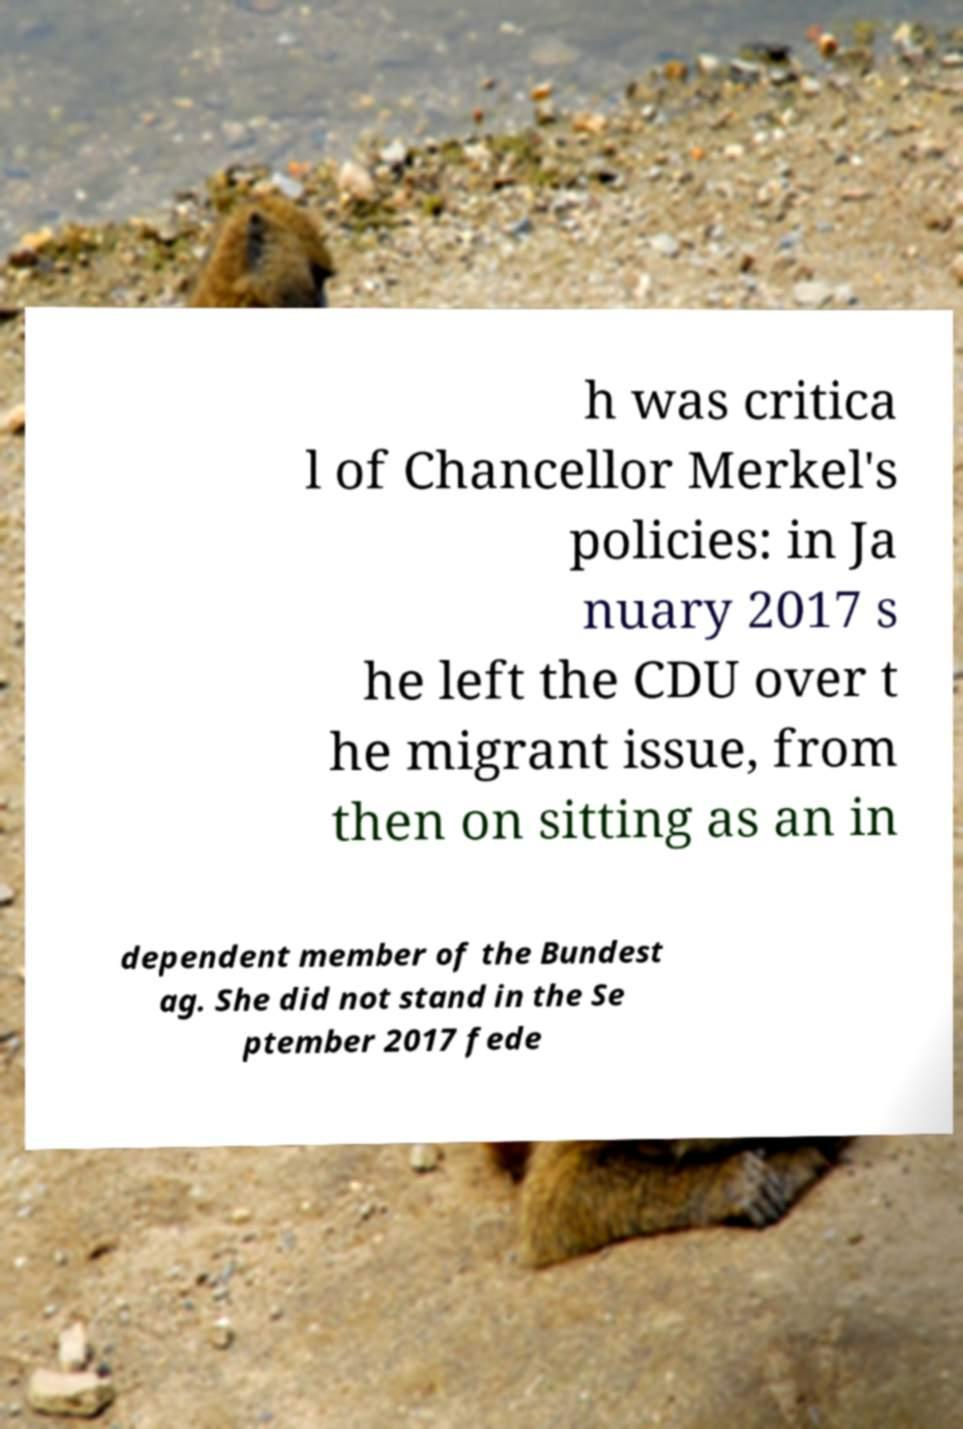Can you accurately transcribe the text from the provided image for me? h was critica l of Chancellor Merkel's policies: in Ja nuary 2017 s he left the CDU over t he migrant issue, from then on sitting as an in dependent member of the Bundest ag. She did not stand in the Se ptember 2017 fede 